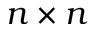<formula> <loc_0><loc_0><loc_500><loc_500>n \times n</formula> 